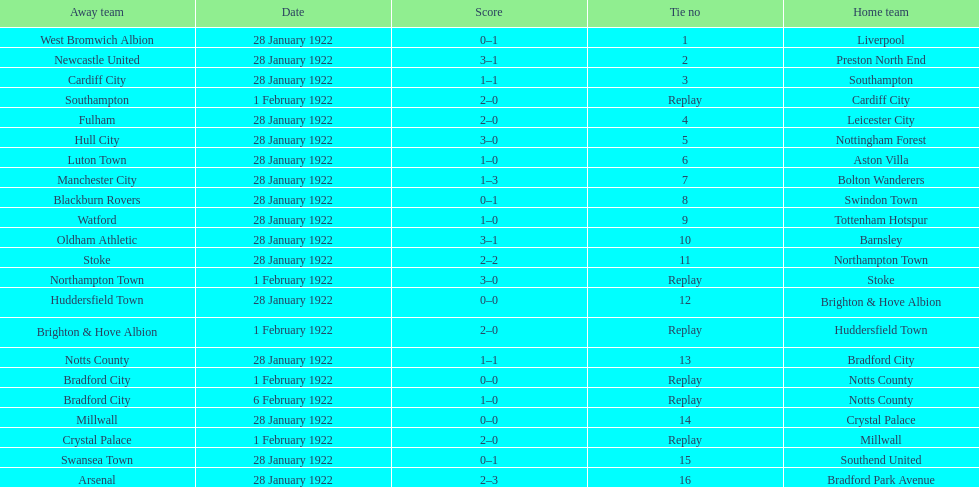What date did they play before feb 1? 28 January 1922. 